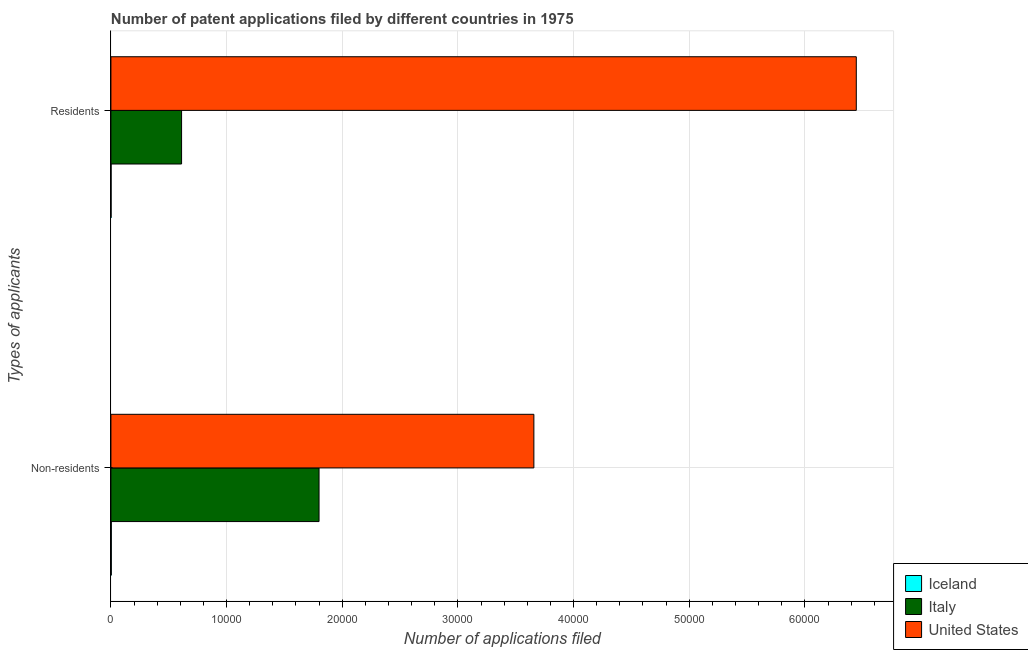How many groups of bars are there?
Your answer should be compact. 2. Are the number of bars per tick equal to the number of legend labels?
Provide a succinct answer. Yes. How many bars are there on the 1st tick from the top?
Provide a short and direct response. 3. How many bars are there on the 1st tick from the bottom?
Ensure brevity in your answer.  3. What is the label of the 1st group of bars from the top?
Offer a very short reply. Residents. What is the number of patent applications by non residents in Iceland?
Your response must be concise. 34. Across all countries, what is the maximum number of patent applications by non residents?
Offer a very short reply. 3.66e+04. Across all countries, what is the minimum number of patent applications by residents?
Give a very brief answer. 14. In which country was the number of patent applications by residents maximum?
Provide a short and direct response. United States. What is the total number of patent applications by non residents in the graph?
Give a very brief answer. 5.46e+04. What is the difference between the number of patent applications by non residents in United States and that in Iceland?
Make the answer very short. 3.65e+04. What is the difference between the number of patent applications by residents in United States and the number of patent applications by non residents in Italy?
Your response must be concise. 4.64e+04. What is the average number of patent applications by residents per country?
Make the answer very short. 2.35e+04. What is the difference between the number of patent applications by non residents and number of patent applications by residents in Iceland?
Ensure brevity in your answer.  20. What is the ratio of the number of patent applications by non residents in Iceland to that in Italy?
Your answer should be very brief. 0. Is the number of patent applications by non residents in Italy less than that in Iceland?
Your answer should be very brief. No. What does the 3rd bar from the bottom in Non-residents represents?
Ensure brevity in your answer.  United States. How many countries are there in the graph?
Ensure brevity in your answer.  3. Are the values on the major ticks of X-axis written in scientific E-notation?
Provide a short and direct response. No. Where does the legend appear in the graph?
Give a very brief answer. Bottom right. What is the title of the graph?
Provide a short and direct response. Number of patent applications filed by different countries in 1975. What is the label or title of the X-axis?
Keep it short and to the point. Number of applications filed. What is the label or title of the Y-axis?
Provide a short and direct response. Types of applicants. What is the Number of applications filed of Iceland in Non-residents?
Your answer should be compact. 34. What is the Number of applications filed in Italy in Non-residents?
Offer a terse response. 1.80e+04. What is the Number of applications filed of United States in Non-residents?
Provide a succinct answer. 3.66e+04. What is the Number of applications filed in Italy in Residents?
Ensure brevity in your answer.  6110. What is the Number of applications filed of United States in Residents?
Your response must be concise. 6.44e+04. Across all Types of applicants, what is the maximum Number of applications filed of Italy?
Provide a short and direct response. 1.80e+04. Across all Types of applicants, what is the maximum Number of applications filed in United States?
Give a very brief answer. 6.44e+04. Across all Types of applicants, what is the minimum Number of applications filed in Iceland?
Your answer should be very brief. 14. Across all Types of applicants, what is the minimum Number of applications filed in Italy?
Offer a terse response. 6110. Across all Types of applicants, what is the minimum Number of applications filed in United States?
Your answer should be very brief. 3.66e+04. What is the total Number of applications filed of Iceland in the graph?
Give a very brief answer. 48. What is the total Number of applications filed in Italy in the graph?
Your answer should be very brief. 2.41e+04. What is the total Number of applications filed in United States in the graph?
Make the answer very short. 1.01e+05. What is the difference between the Number of applications filed of Italy in Non-residents and that in Residents?
Provide a succinct answer. 1.19e+04. What is the difference between the Number of applications filed of United States in Non-residents and that in Residents?
Keep it short and to the point. -2.79e+04. What is the difference between the Number of applications filed in Iceland in Non-residents and the Number of applications filed in Italy in Residents?
Provide a succinct answer. -6076. What is the difference between the Number of applications filed in Iceland in Non-residents and the Number of applications filed in United States in Residents?
Ensure brevity in your answer.  -6.44e+04. What is the difference between the Number of applications filed of Italy in Non-residents and the Number of applications filed of United States in Residents?
Ensure brevity in your answer.  -4.64e+04. What is the average Number of applications filed in Iceland per Types of applicants?
Offer a very short reply. 24. What is the average Number of applications filed of Italy per Types of applicants?
Provide a short and direct response. 1.21e+04. What is the average Number of applications filed of United States per Types of applicants?
Your answer should be compact. 5.05e+04. What is the difference between the Number of applications filed of Iceland and Number of applications filed of Italy in Non-residents?
Provide a succinct answer. -1.80e+04. What is the difference between the Number of applications filed of Iceland and Number of applications filed of United States in Non-residents?
Offer a terse response. -3.65e+04. What is the difference between the Number of applications filed of Italy and Number of applications filed of United States in Non-residents?
Offer a terse response. -1.86e+04. What is the difference between the Number of applications filed of Iceland and Number of applications filed of Italy in Residents?
Keep it short and to the point. -6096. What is the difference between the Number of applications filed of Iceland and Number of applications filed of United States in Residents?
Offer a terse response. -6.44e+04. What is the difference between the Number of applications filed of Italy and Number of applications filed of United States in Residents?
Keep it short and to the point. -5.83e+04. What is the ratio of the Number of applications filed in Iceland in Non-residents to that in Residents?
Offer a terse response. 2.43. What is the ratio of the Number of applications filed in Italy in Non-residents to that in Residents?
Provide a succinct answer. 2.95. What is the ratio of the Number of applications filed of United States in Non-residents to that in Residents?
Your response must be concise. 0.57. What is the difference between the highest and the second highest Number of applications filed of Italy?
Your response must be concise. 1.19e+04. What is the difference between the highest and the second highest Number of applications filed in United States?
Your answer should be compact. 2.79e+04. What is the difference between the highest and the lowest Number of applications filed in Iceland?
Provide a short and direct response. 20. What is the difference between the highest and the lowest Number of applications filed in Italy?
Give a very brief answer. 1.19e+04. What is the difference between the highest and the lowest Number of applications filed of United States?
Your answer should be compact. 2.79e+04. 